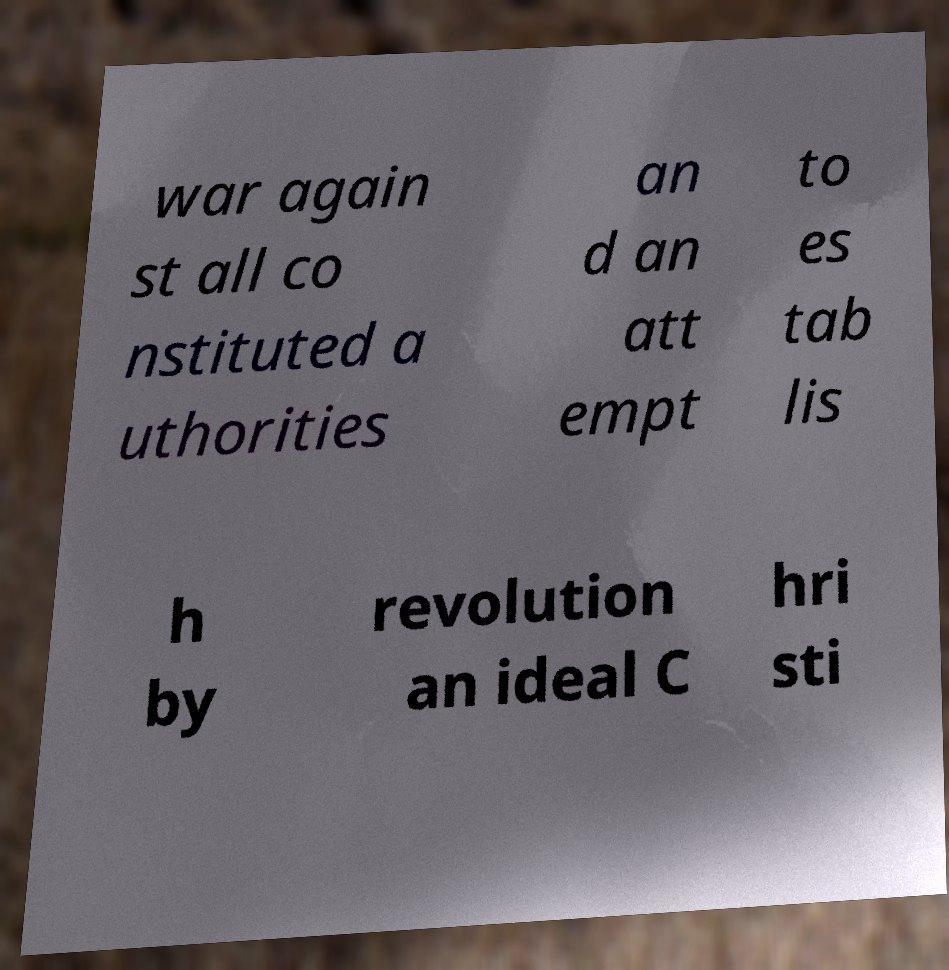Could you extract and type out the text from this image? war again st all co nstituted a uthorities an d an att empt to es tab lis h by revolution an ideal C hri sti 